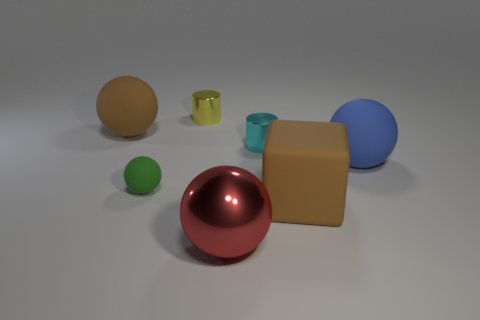What size is the metal ball in front of the large brown rubber object in front of the brown object that is behind the small green rubber ball?
Ensure brevity in your answer.  Large. There is another tiny object that is the same shape as the yellow metallic object; what is its material?
Ensure brevity in your answer.  Metal. Is there anything else that is the same size as the brown matte block?
Keep it short and to the point. Yes. There is a thing on the right side of the large brown rubber thing that is on the right side of the tiny yellow metallic object; what is its size?
Provide a short and direct response. Large. What color is the large block?
Provide a short and direct response. Brown. What number of big matte objects are to the left of the block that is in front of the tiny rubber sphere?
Provide a succinct answer. 1. Are there any large brown cubes in front of the big brown block on the right side of the tiny sphere?
Offer a terse response. No. Are there any brown matte things on the left side of the red thing?
Your answer should be compact. Yes. There is a big brown matte thing on the left side of the tiny rubber sphere; is its shape the same as the tiny cyan shiny object?
Give a very brief answer. No. What number of big blue matte things are the same shape as the red object?
Keep it short and to the point. 1. 